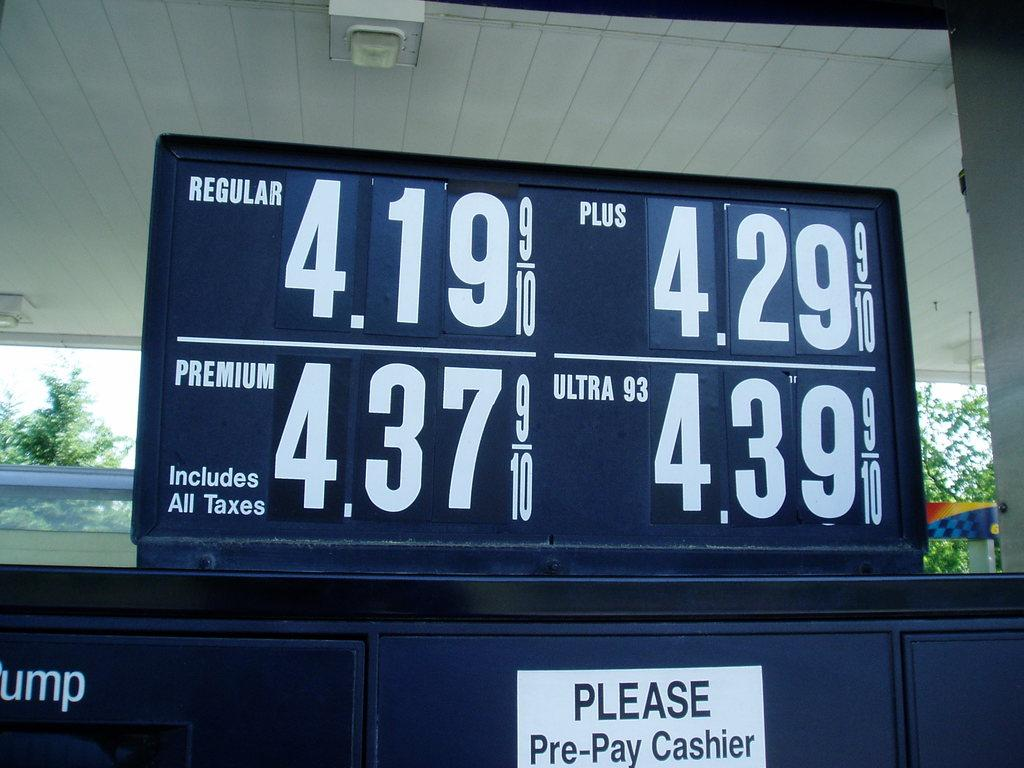<image>
Share a concise interpretation of the image provided. Price of the gas with a white sign that says to pre pay at cashier. 